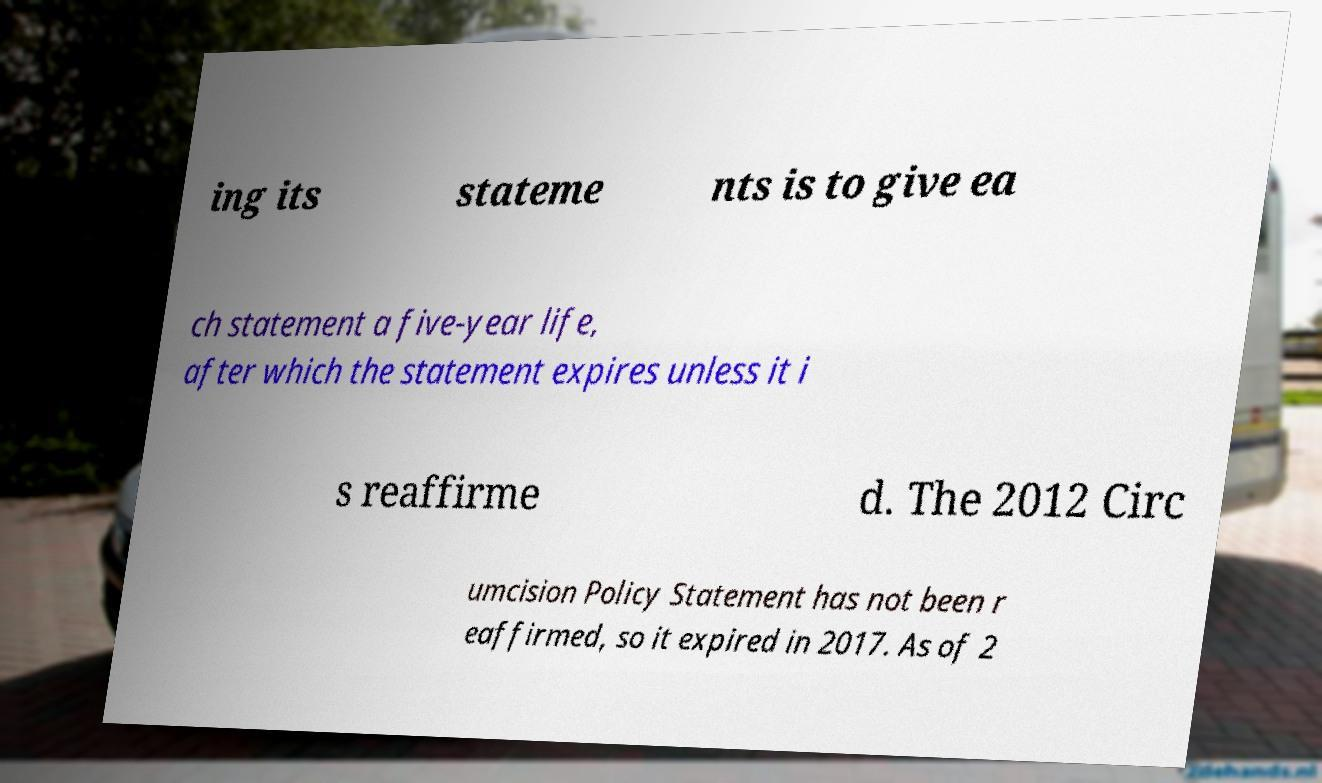Could you assist in decoding the text presented in this image and type it out clearly? ing its stateme nts is to give ea ch statement a five-year life, after which the statement expires unless it i s reaffirme d. The 2012 Circ umcision Policy Statement has not been r eaffirmed, so it expired in 2017. As of 2 